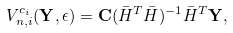Convert formula to latex. <formula><loc_0><loc_0><loc_500><loc_500>V _ { n , i } ^ { c _ { i } } ( { \mathbf Y } , \epsilon ) = { \mathbf C } ( \bar { H } ^ { T } \bar { H } ) ^ { - 1 } \bar { H } ^ { T } { \mathbf Y } ,</formula> 